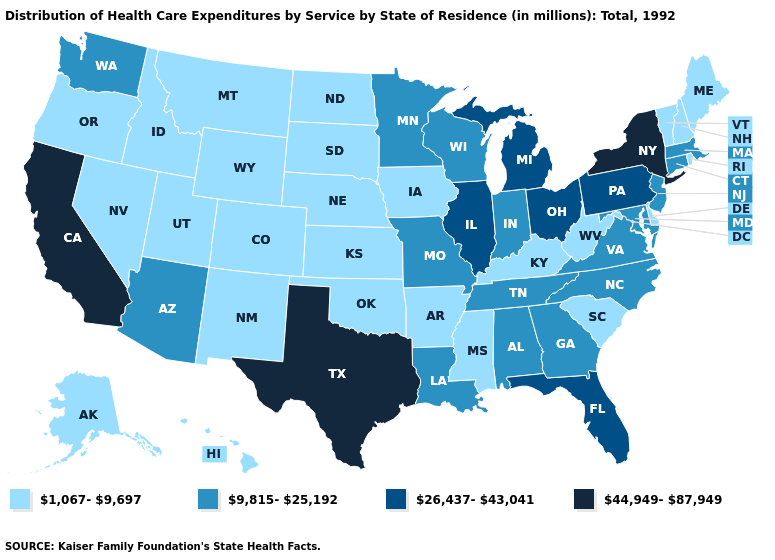Is the legend a continuous bar?
Give a very brief answer. No. What is the value of New York?
Keep it brief. 44,949-87,949. What is the value of Montana?
Concise answer only. 1,067-9,697. What is the value of Colorado?
Be succinct. 1,067-9,697. Does Illinois have the lowest value in the USA?
Be succinct. No. What is the highest value in the Northeast ?
Quick response, please. 44,949-87,949. What is the highest value in states that border California?
Be succinct. 9,815-25,192. Does South Dakota have the highest value in the MidWest?
Answer briefly. No. What is the highest value in the USA?
Concise answer only. 44,949-87,949. What is the value of Georgia?
Quick response, please. 9,815-25,192. What is the value of Utah?
Concise answer only. 1,067-9,697. What is the lowest value in states that border New York?
Give a very brief answer. 1,067-9,697. What is the value of Colorado?
Give a very brief answer. 1,067-9,697. What is the highest value in the Northeast ?
Be succinct. 44,949-87,949. Does Virginia have the highest value in the USA?
Concise answer only. No. 